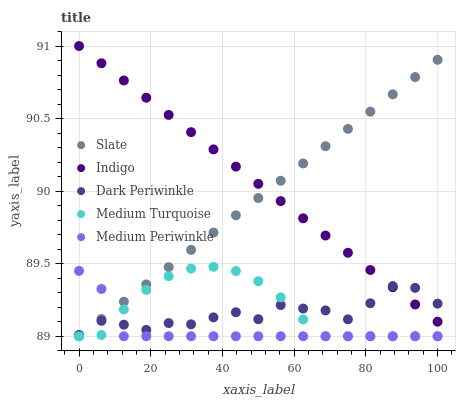Does Medium Periwinkle have the minimum area under the curve?
Answer yes or no. Yes. Does Indigo have the maximum area under the curve?
Answer yes or no. Yes. Does Slate have the minimum area under the curve?
Answer yes or no. No. Does Slate have the maximum area under the curve?
Answer yes or no. No. Is Indigo the smoothest?
Answer yes or no. Yes. Is Dark Periwinkle the roughest?
Answer yes or no. Yes. Is Slate the smoothest?
Answer yes or no. No. Is Slate the roughest?
Answer yes or no. No. Does Medium Periwinkle have the lowest value?
Answer yes or no. Yes. Does Indigo have the lowest value?
Answer yes or no. No. Does Indigo have the highest value?
Answer yes or no. Yes. Does Slate have the highest value?
Answer yes or no. No. Is Medium Periwinkle less than Indigo?
Answer yes or no. Yes. Is Indigo greater than Medium Periwinkle?
Answer yes or no. Yes. Does Medium Turquoise intersect Dark Periwinkle?
Answer yes or no. Yes. Is Medium Turquoise less than Dark Periwinkle?
Answer yes or no. No. Is Medium Turquoise greater than Dark Periwinkle?
Answer yes or no. No. Does Medium Periwinkle intersect Indigo?
Answer yes or no. No. 